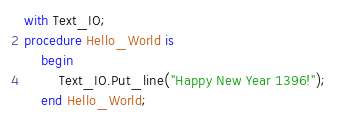<code> <loc_0><loc_0><loc_500><loc_500><_Ada_>with Text_IO;
procedure Hello_World is
	begin
		Text_IO.Put_line("Happy New Year 1396!");
	end Hello_World;
</code> 